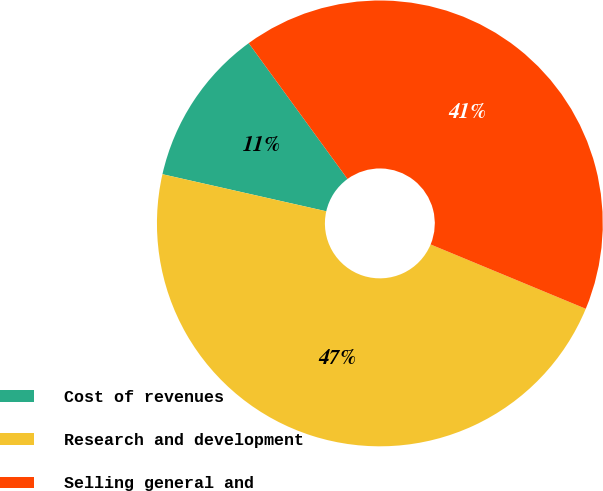<chart> <loc_0><loc_0><loc_500><loc_500><pie_chart><fcel>Cost of revenues<fcel>Research and development<fcel>Selling general and<nl><fcel>11.45%<fcel>47.29%<fcel>41.27%<nl></chart> 